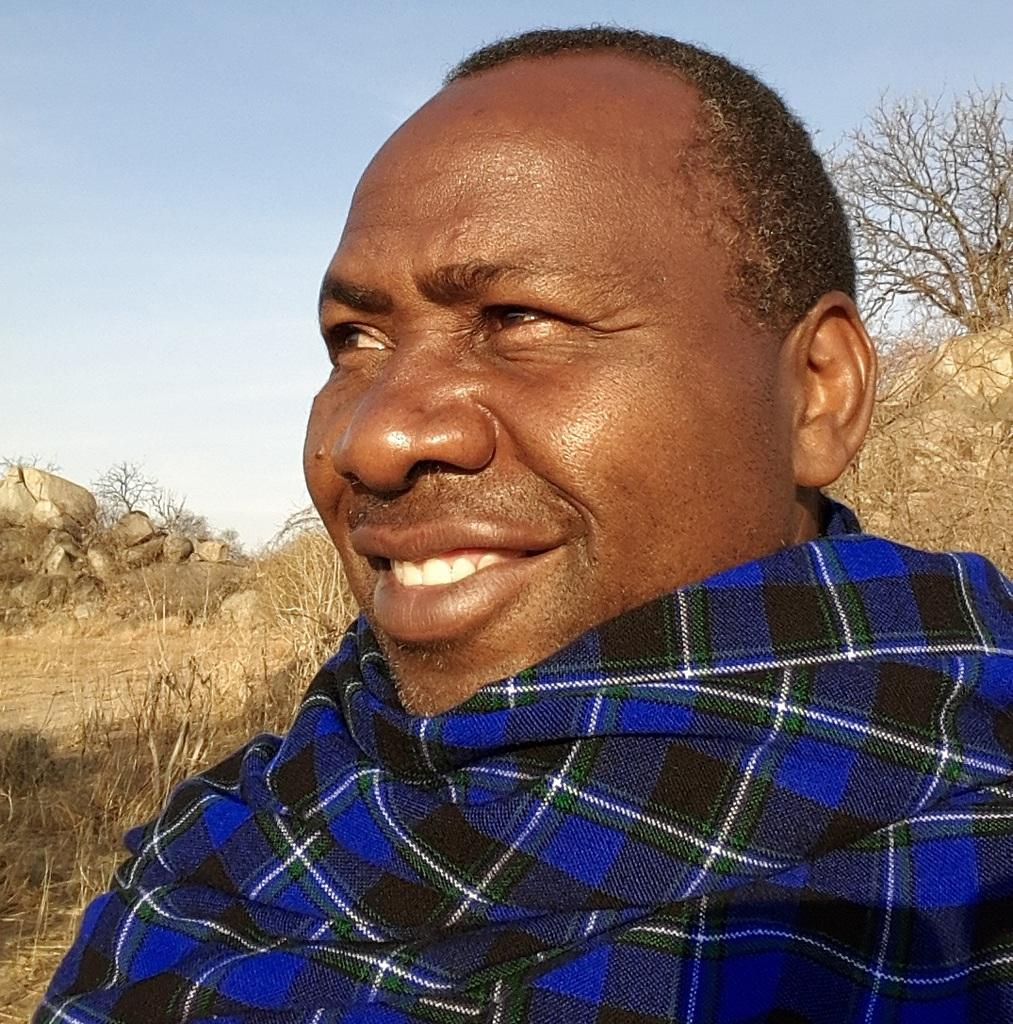Who is present in the image? There is a person in the image. What colors can be seen in the person's clothing? The person is wearing blue, black, and white clothing. What is the person's facial expression in the image? The person is smiling. What type of natural environment is visible in the background of the image? There are rocks, trees, the ground, and the sky visible in the background of the image. What type of music is the person playing in the image? There is no indication in the image that the person is playing music, so it cannot be determined from the picture. 